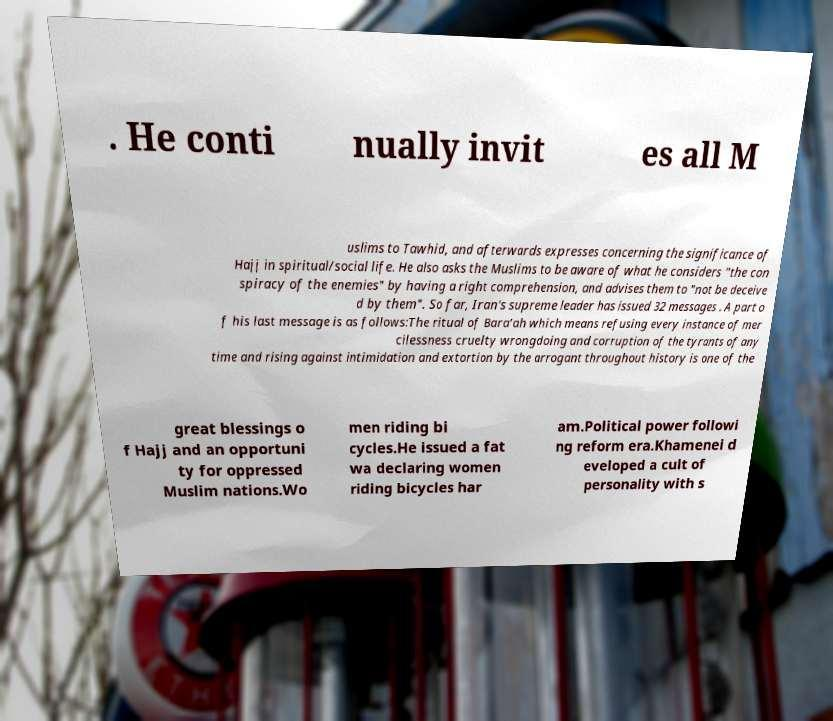For documentation purposes, I need the text within this image transcribed. Could you provide that? . He conti nually invit es all M uslims to Tawhid, and afterwards expresses concerning the significance of Hajj in spiritual/social life. He also asks the Muslims to be aware of what he considers "the con spiracy of the enemies" by having a right comprehension, and advises them to "not be deceive d by them". So far, Iran's supreme leader has issued 32 messages . A part o f his last message is as follows:The ritual of Bara’ah which means refusing every instance of mer cilessness cruelty wrongdoing and corruption of the tyrants of any time and rising against intimidation and extortion by the arrogant throughout history is one of the great blessings o f Hajj and an opportuni ty for oppressed Muslim nations.Wo men riding bi cycles.He issued a fat wa declaring women riding bicycles har am.Political power followi ng reform era.Khamenei d eveloped a cult of personality with s 